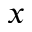<formula> <loc_0><loc_0><loc_500><loc_500>x</formula> 